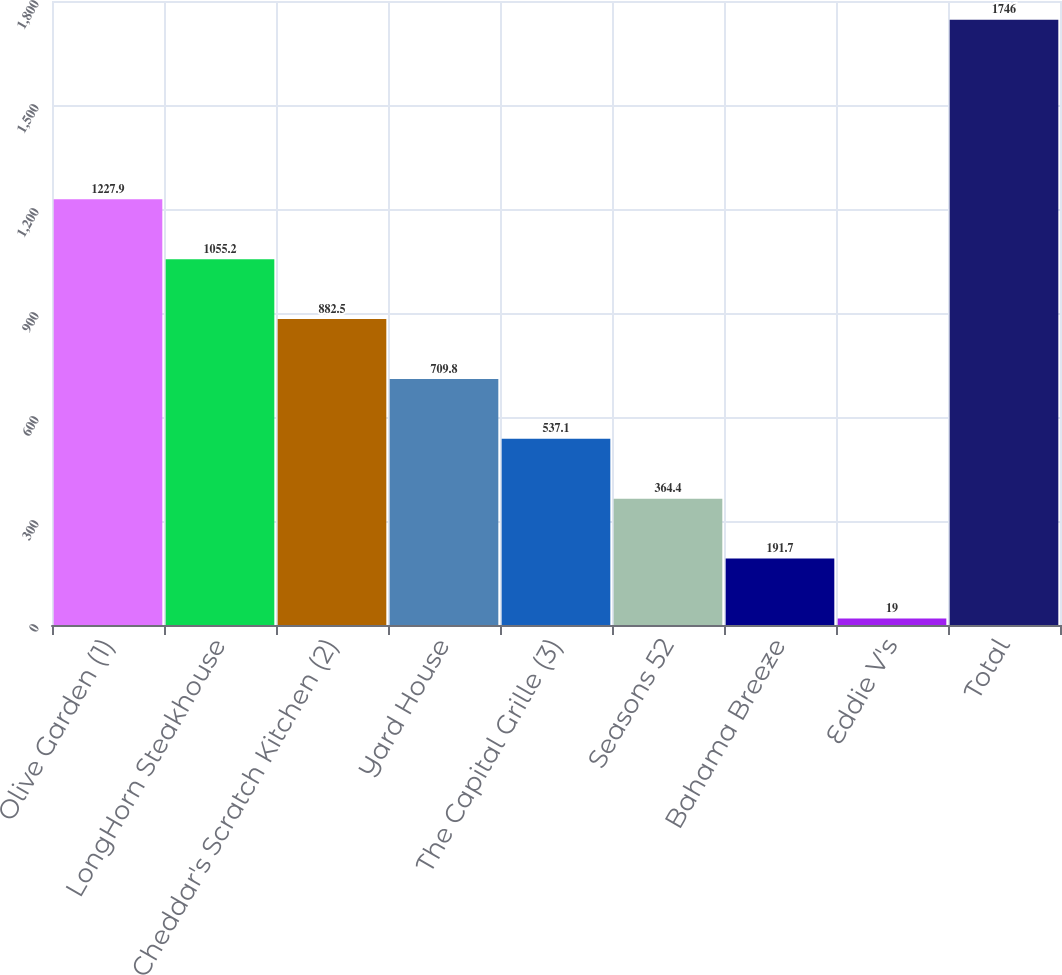Convert chart to OTSL. <chart><loc_0><loc_0><loc_500><loc_500><bar_chart><fcel>Olive Garden (1)<fcel>LongHorn Steakhouse<fcel>Cheddar's Scratch Kitchen (2)<fcel>Yard House<fcel>The Capital Grille (3)<fcel>Seasons 52<fcel>Bahama Breeze<fcel>Eddie V's<fcel>Total<nl><fcel>1227.9<fcel>1055.2<fcel>882.5<fcel>709.8<fcel>537.1<fcel>364.4<fcel>191.7<fcel>19<fcel>1746<nl></chart> 